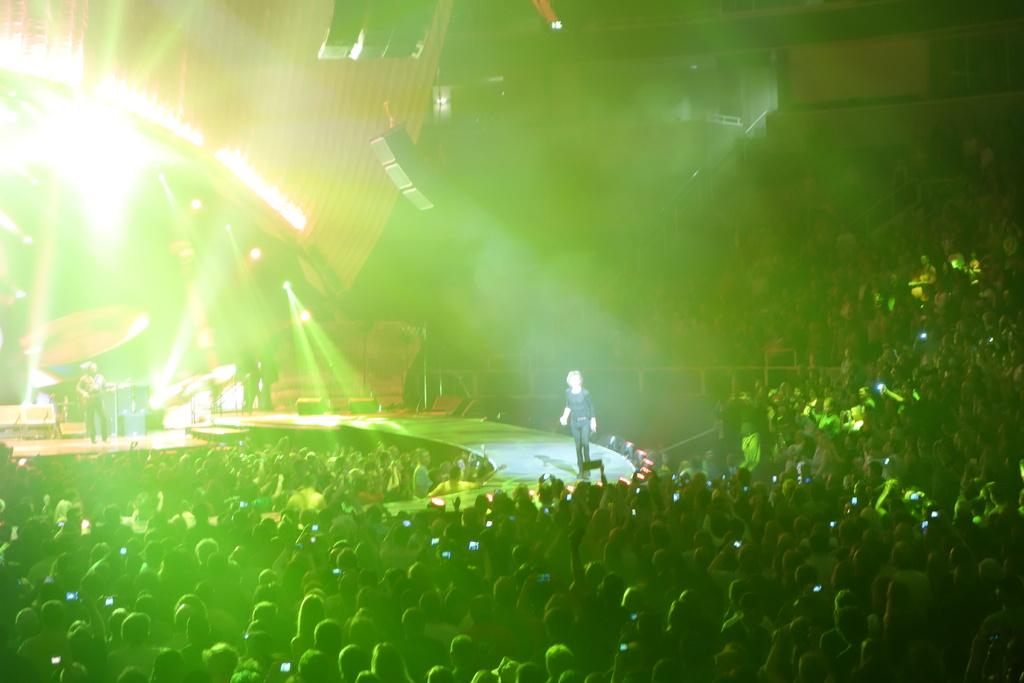What are the people in the image doing? There are people on a path and standing on a stage in the image. What can be seen in the background of the image? There are lights visible in the image. What is the presence of smoke in the image indicative of? The smoke in the image suggests that there might be a performance or event taking place. What equipment is present in the image that might be used for music? There are musical systems in the image. What type of soda is being served from the expansion tank in the image? There is no soda or expansion tank present in the image. 